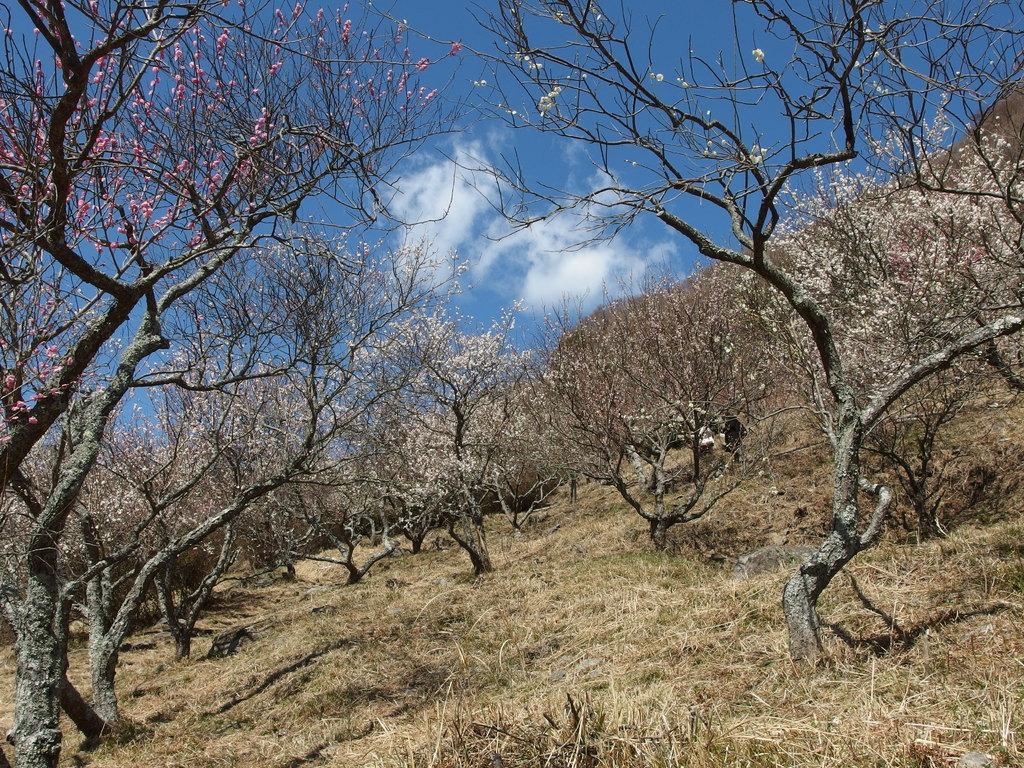Can you describe this image briefly? In this image I can see the ground, some grass on the ground, few trees and few flowers to the trees which are pink and white in color. In the background I can see the sky. 